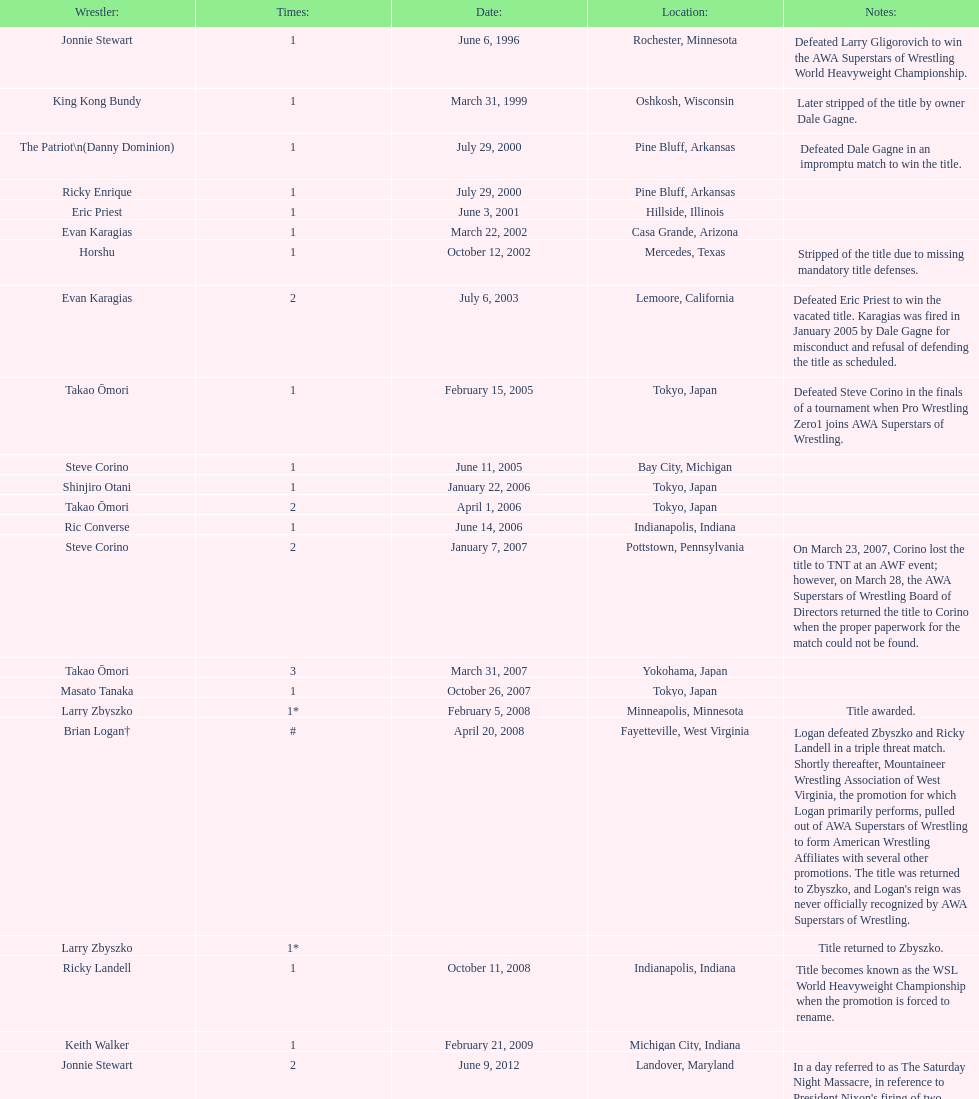When did steve corino achieve his first wsl championship victory? June 11, 2005. 